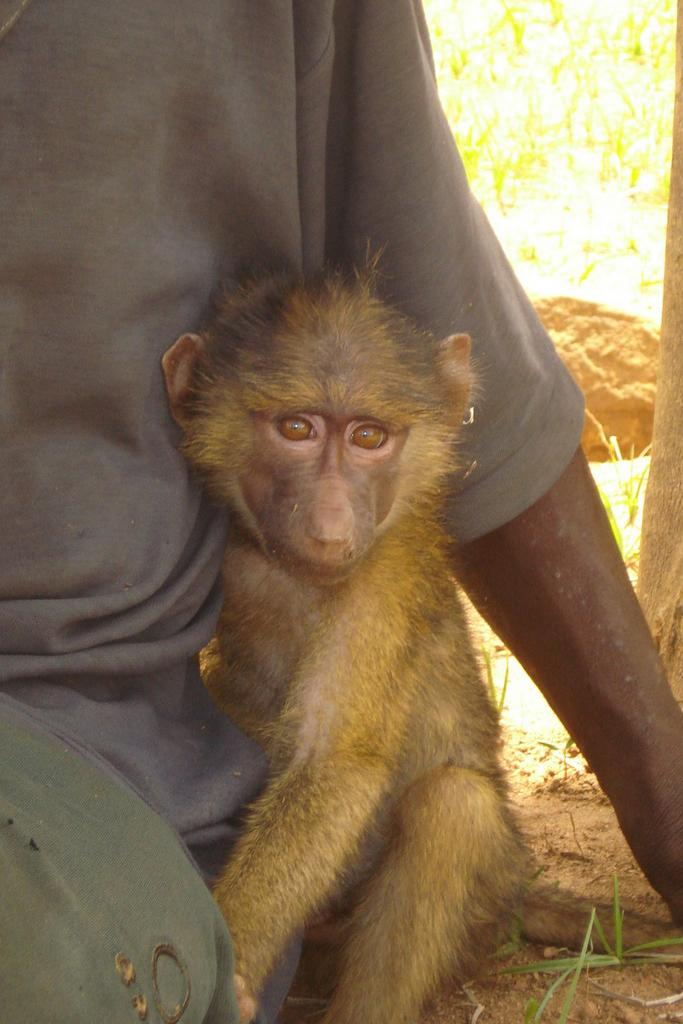What animal is present in the image? There is a monkey in the image. What is the monkey doing in the image? The monkey is sitting on the ground. Who or what is near the monkey? The monkey is beside a person. What can be seen in the background of the image? There is a stone in the background of the image. What type of ground is visible in the image? There is sand on the ground. What is located on the right side of the image? There is a tree on the right side of the image. What time of day is it in the image? The time of day cannot be determined from the image alone. 